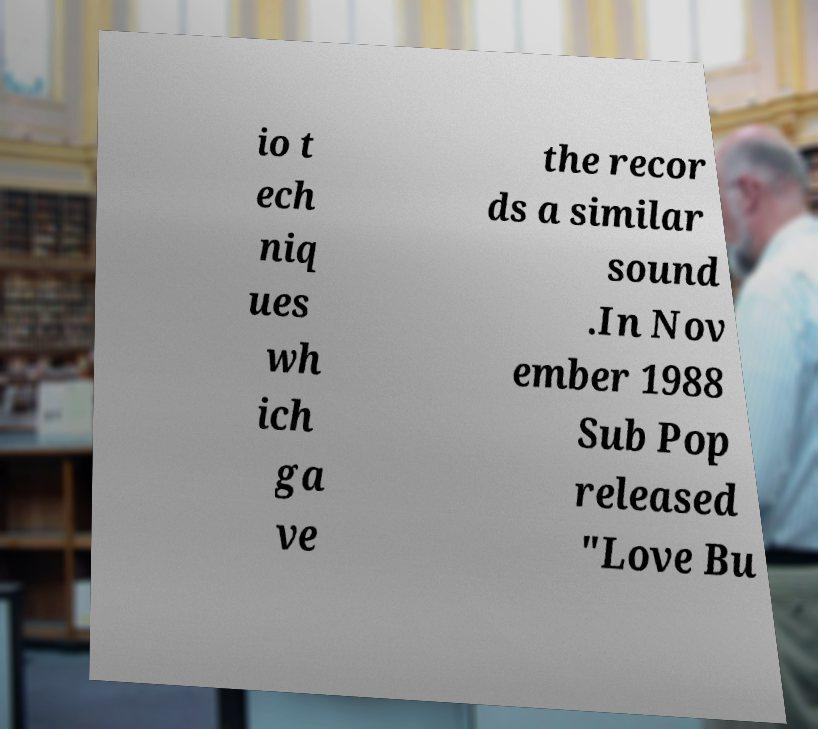Can you read and provide the text displayed in the image?This photo seems to have some interesting text. Can you extract and type it out for me? io t ech niq ues wh ich ga ve the recor ds a similar sound .In Nov ember 1988 Sub Pop released "Love Bu 